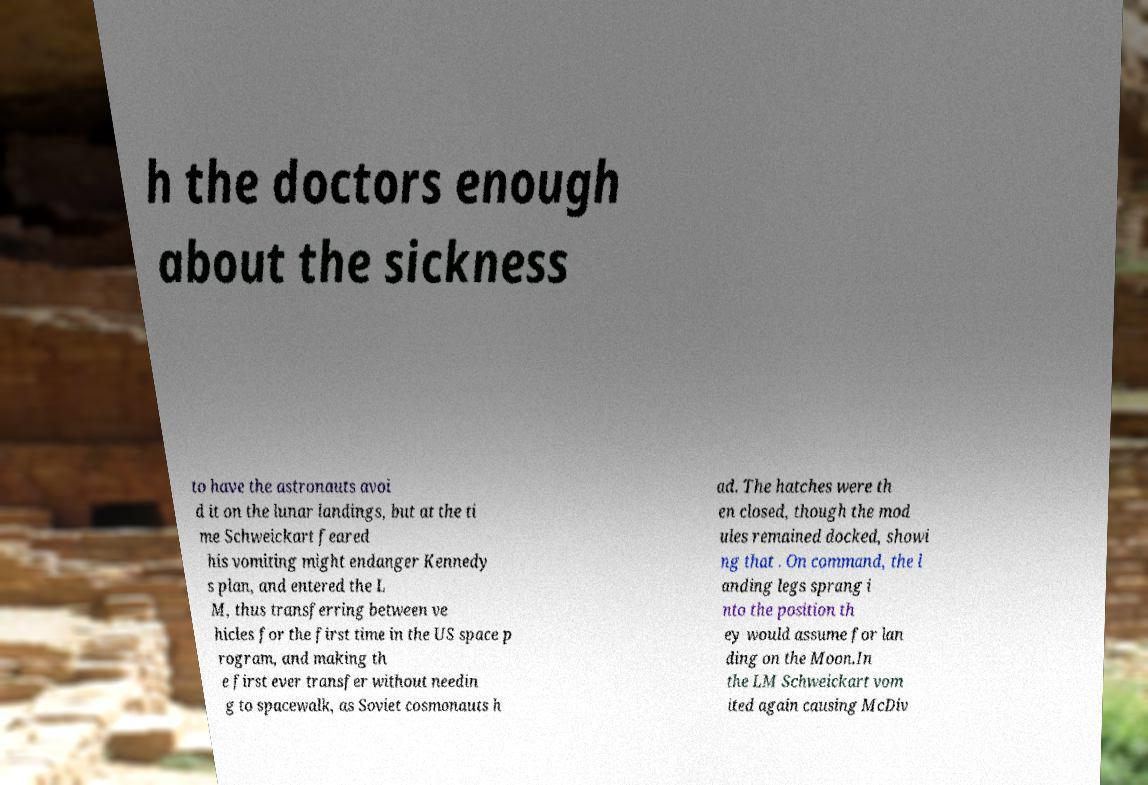Please identify and transcribe the text found in this image. h the doctors enough about the sickness to have the astronauts avoi d it on the lunar landings, but at the ti me Schweickart feared his vomiting might endanger Kennedy s plan, and entered the L M, thus transferring between ve hicles for the first time in the US space p rogram, and making th e first ever transfer without needin g to spacewalk, as Soviet cosmonauts h ad. The hatches were th en closed, though the mod ules remained docked, showi ng that . On command, the l anding legs sprang i nto the position th ey would assume for lan ding on the Moon.In the LM Schweickart vom ited again causing McDiv 